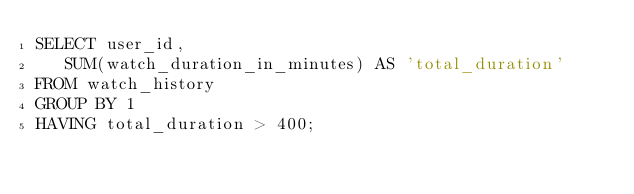<code> <loc_0><loc_0><loc_500><loc_500><_SQL_>SELECT user_id, 
   SUM(watch_duration_in_minutes) AS 'total_duration'
FROM watch_history
GROUP BY 1
HAVING total_duration > 400;</code> 